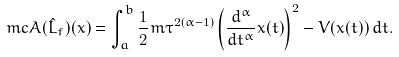Convert formula to latex. <formula><loc_0><loc_0><loc_500><loc_500>\ m c { A } ( \hat { L } _ { f } ) ( x ) = \int _ { a } ^ { b } \frac { 1 } { 2 } m \tau ^ { 2 ( \alpha - 1 ) } \left ( \frac { d ^ { \alpha } } { d t ^ { \alpha } } x ( t ) \right ) ^ { 2 } - V ( x ( t ) ) \, d t .</formula> 